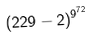<formula> <loc_0><loc_0><loc_500><loc_500>( 2 2 9 - 2 ) ^ { 9 ^ { 7 2 } }</formula> 